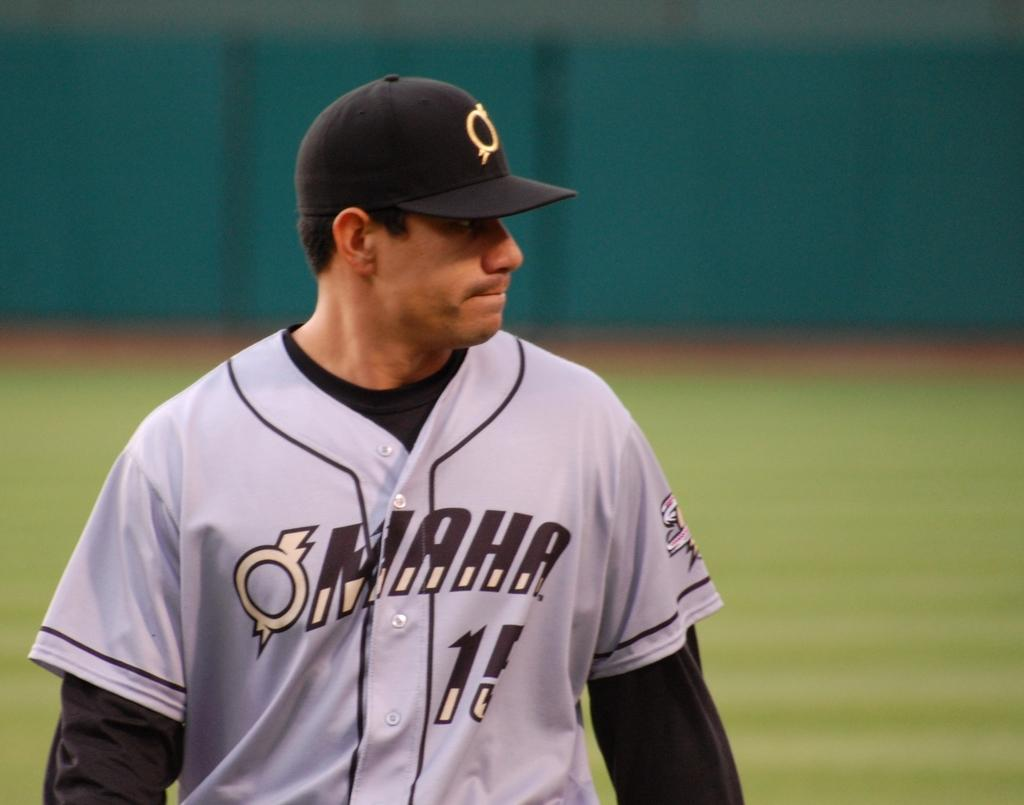<image>
Offer a succinct explanation of the picture presented. A baseball pitcher is getting ready to throw the ball and his jersey says Omaha 15. 